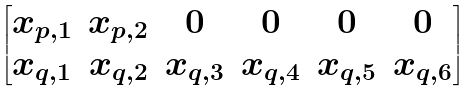Convert formula to latex. <formula><loc_0><loc_0><loc_500><loc_500>\begin{bmatrix} x _ { p , 1 } & x _ { p , 2 } & 0 & 0 & 0 & 0 \\ x _ { q , 1 } & x _ { q , 2 } & x _ { q , 3 } & x _ { q , 4 } & x _ { q , 5 } & x _ { q , 6 } \end{bmatrix}</formula> 